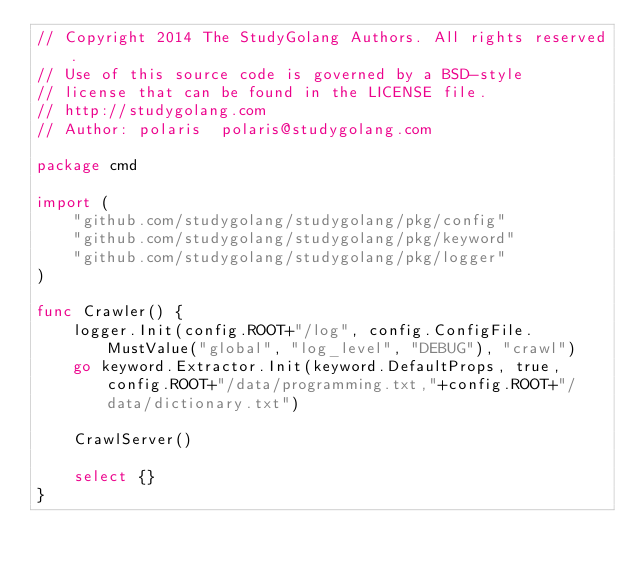<code> <loc_0><loc_0><loc_500><loc_500><_Go_>// Copyright 2014 The StudyGolang Authors. All rights reserved.
// Use of this source code is governed by a BSD-style
// license that can be found in the LICENSE file.
// http://studygolang.com
// Author: polaris	polaris@studygolang.com

package cmd

import (
	"github.com/studygolang/studygolang/pkg/config"
	"github.com/studygolang/studygolang/pkg/keyword"
	"github.com/studygolang/studygolang/pkg/logger"
)

func Crawler() {
	logger.Init(config.ROOT+"/log", config.ConfigFile.MustValue("global", "log_level", "DEBUG"), "crawl")
	go keyword.Extractor.Init(keyword.DefaultProps, true, config.ROOT+"/data/programming.txt,"+config.ROOT+"/data/dictionary.txt")

	CrawlServer()

	select {}
}
</code> 